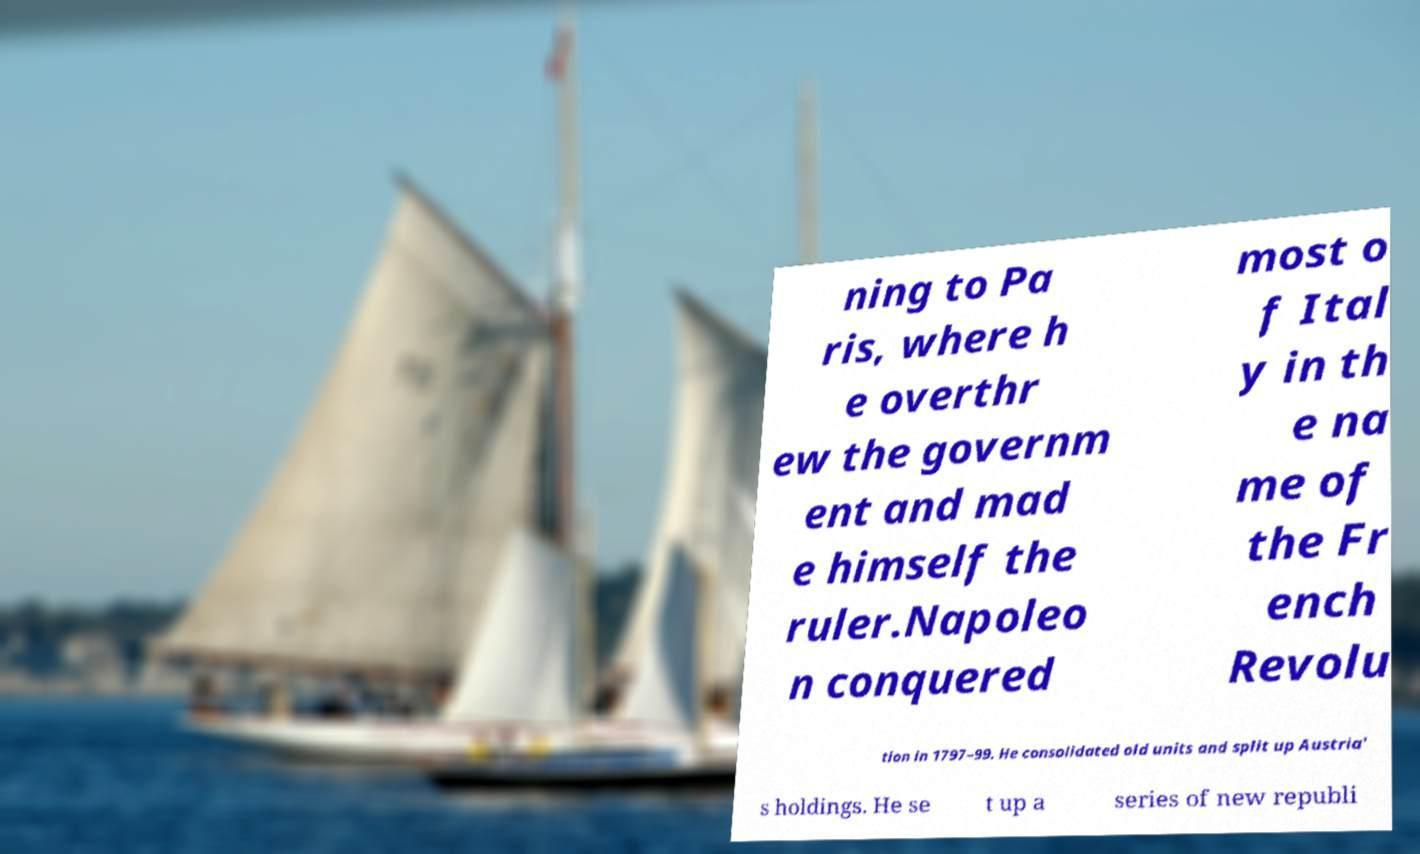There's text embedded in this image that I need extracted. Can you transcribe it verbatim? ning to Pa ris, where h e overthr ew the governm ent and mad e himself the ruler.Napoleo n conquered most o f Ital y in th e na me of the Fr ench Revolu tion in 1797–99. He consolidated old units and split up Austria' s holdings. He se t up a series of new republi 